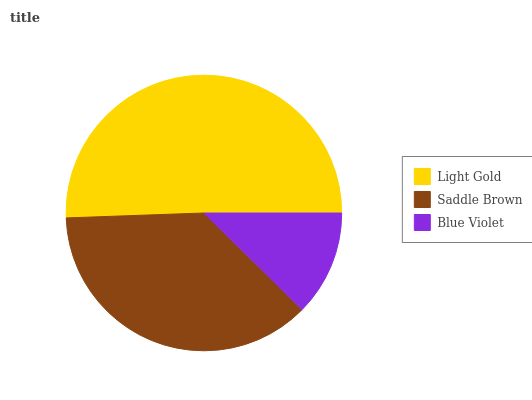Is Blue Violet the minimum?
Answer yes or no. Yes. Is Light Gold the maximum?
Answer yes or no. Yes. Is Saddle Brown the minimum?
Answer yes or no. No. Is Saddle Brown the maximum?
Answer yes or no. No. Is Light Gold greater than Saddle Brown?
Answer yes or no. Yes. Is Saddle Brown less than Light Gold?
Answer yes or no. Yes. Is Saddle Brown greater than Light Gold?
Answer yes or no. No. Is Light Gold less than Saddle Brown?
Answer yes or no. No. Is Saddle Brown the high median?
Answer yes or no. Yes. Is Saddle Brown the low median?
Answer yes or no. Yes. Is Blue Violet the high median?
Answer yes or no. No. Is Blue Violet the low median?
Answer yes or no. No. 